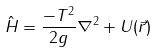Convert formula to latex. <formula><loc_0><loc_0><loc_500><loc_500>\hat { H } = \frac { - T ^ { 2 } } { 2 g } \nabla ^ { 2 } + U ( \vec { r } )</formula> 